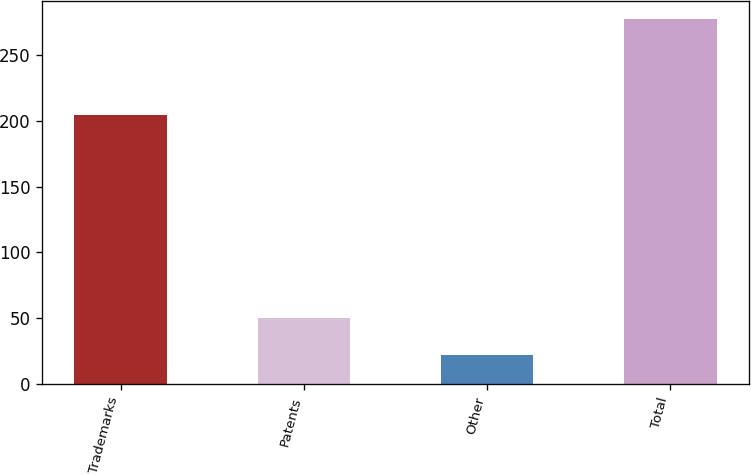<chart> <loc_0><loc_0><loc_500><loc_500><bar_chart><fcel>Trademarks<fcel>Patents<fcel>Other<fcel>Total<nl><fcel>204.1<fcel>50.5<fcel>22.2<fcel>276.8<nl></chart> 